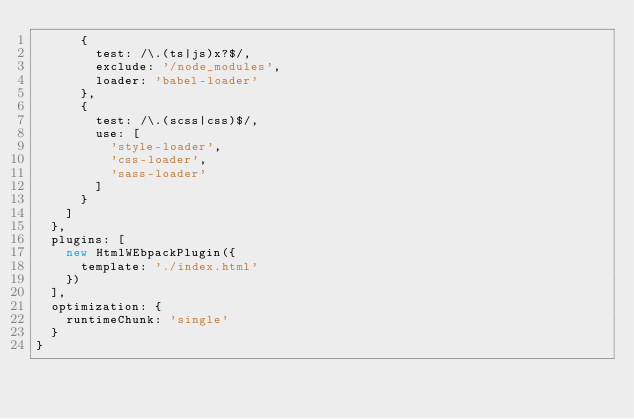<code> <loc_0><loc_0><loc_500><loc_500><_JavaScript_>      {
        test: /\.(ts|js)x?$/,
        exclude: '/node_modules',
        loader: 'babel-loader'
      },
      {
        test: /\.(scss|css)$/,
        use: [
          'style-loader',
          'css-loader',
          'sass-loader'
        ]
      }
    ]
  },
  plugins: [
    new HtmlWEbpackPlugin({
      template: './index.html'
    })
  ],
  optimization: {
    runtimeChunk: 'single'
  }
}</code> 